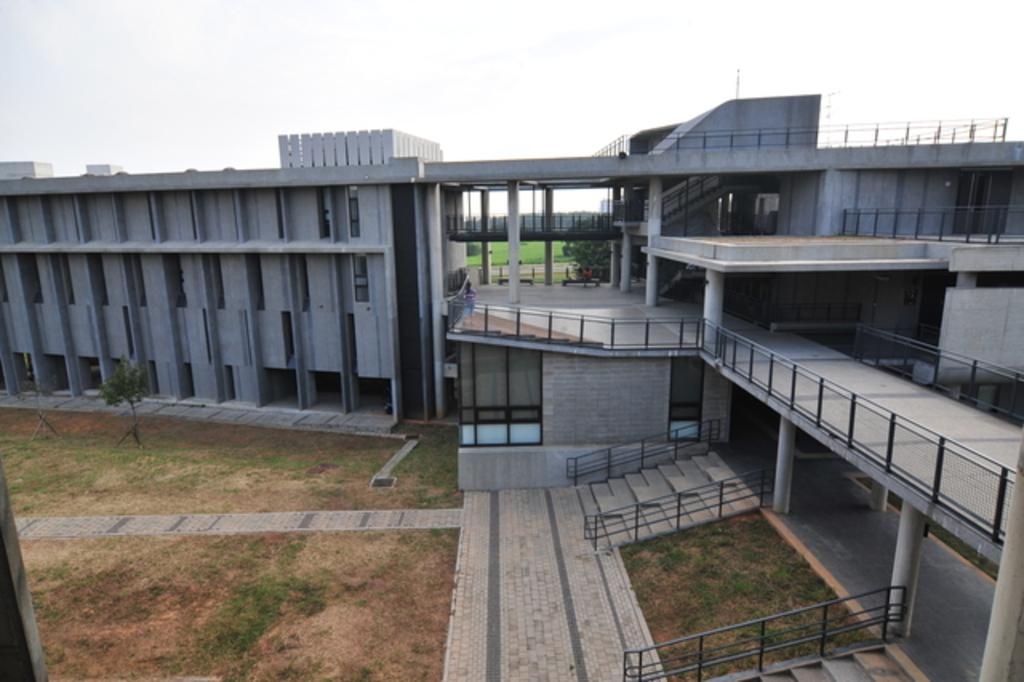What is the main structure in the image? There is a building in the front of the image. What type of landscape is visible behind the building? There is a grassland behind the building. What part of the natural environment is visible in the image? The sky is visible above the building and grassland. What type of question is being asked in the image? There is no question present in the image; it is a visual representation of a building, grassland, and sky. 